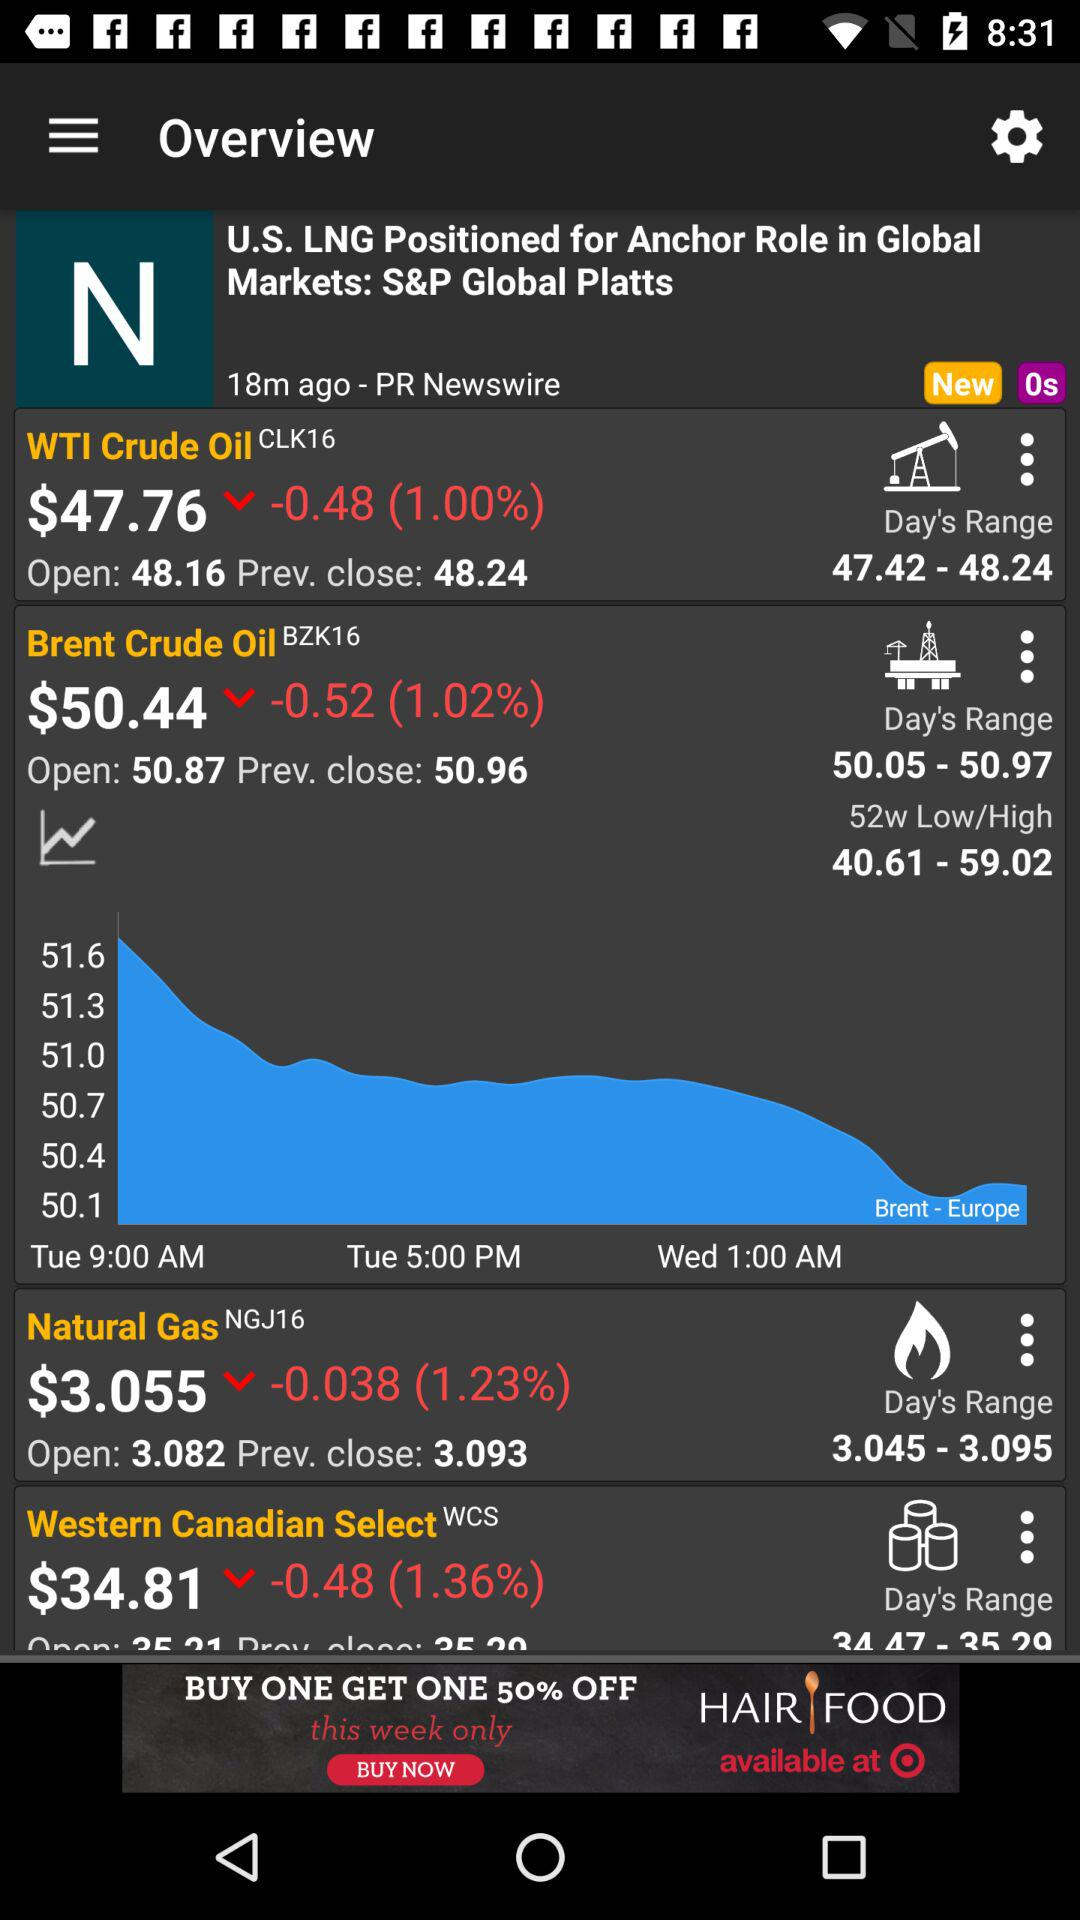What is the current percentage change in the "Natural Gas" derivatives? The current percentage change is 1.23. 